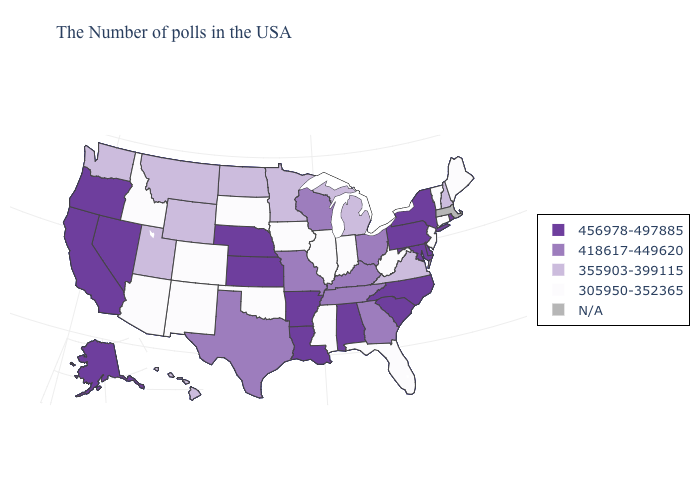What is the value of Oregon?
Quick response, please. 456978-497885. What is the value of North Carolina?
Quick response, please. 456978-497885. Which states have the lowest value in the USA?
Be succinct. Maine, Vermont, Connecticut, New Jersey, West Virginia, Florida, Indiana, Illinois, Mississippi, Iowa, Oklahoma, South Dakota, Colorado, New Mexico, Arizona, Idaho. Among the states that border Minnesota , does North Dakota have the lowest value?
Give a very brief answer. No. Among the states that border West Virginia , does Virginia have the highest value?
Short answer required. No. What is the value of Minnesota?
Quick response, please. 355903-399115. What is the lowest value in the USA?
Answer briefly. 305950-352365. What is the highest value in the MidWest ?
Quick response, please. 456978-497885. Does the map have missing data?
Be succinct. Yes. Among the states that border Utah , does Idaho have the highest value?
Quick response, please. No. Does Kentucky have the lowest value in the USA?
Keep it brief. No. Name the states that have a value in the range N/A?
Concise answer only. Massachusetts. What is the value of Indiana?
Be succinct. 305950-352365. What is the value of Louisiana?
Keep it brief. 456978-497885. 